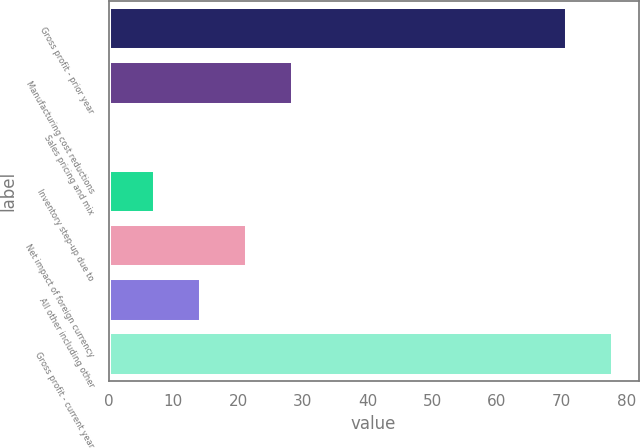Convert chart to OTSL. <chart><loc_0><loc_0><loc_500><loc_500><bar_chart><fcel>Gross profit - prior year<fcel>Manufacturing cost reductions<fcel>Sales pricing and mix<fcel>Inventory step-up due to<fcel>Net impact of foreign currency<fcel>All other including other<fcel>Gross profit - current year<nl><fcel>70.9<fcel>28.5<fcel>0.1<fcel>7.2<fcel>21.4<fcel>14.3<fcel>78<nl></chart> 